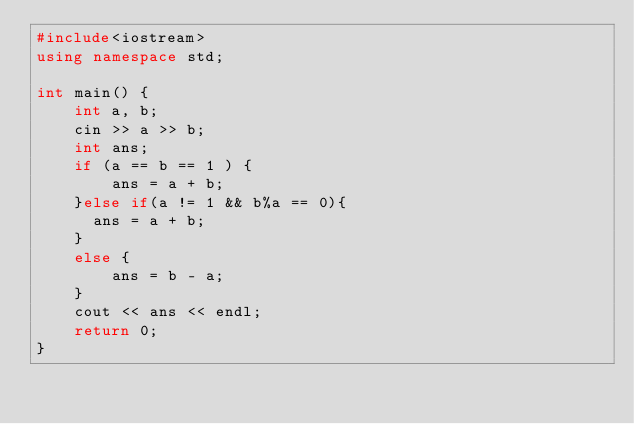<code> <loc_0><loc_0><loc_500><loc_500><_C++_>#include<iostream>
using namespace std;

int main() {
	int a, b;
	cin >> a >> b;
	int ans;
	if (a == b == 1 ) {
		ans = a + b;
	}else if(a != 1 && b%a == 0){
      ans = a + b;
    }
	else {
		ans = b - a;
	}
	cout << ans << endl;
	return 0;
}</code> 